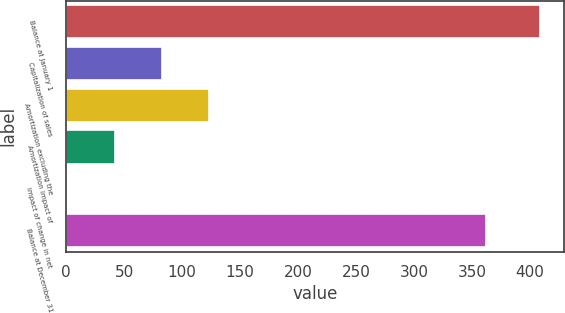<chart> <loc_0><loc_0><loc_500><loc_500><bar_chart><fcel>Balance at January 1<fcel>Capitalization of sales<fcel>Amortization excluding the<fcel>Amortization impact of<fcel>Impact of change in net<fcel>Balance at December 31<nl><fcel>409<fcel>82.6<fcel>123.4<fcel>41.8<fcel>1<fcel>362<nl></chart> 